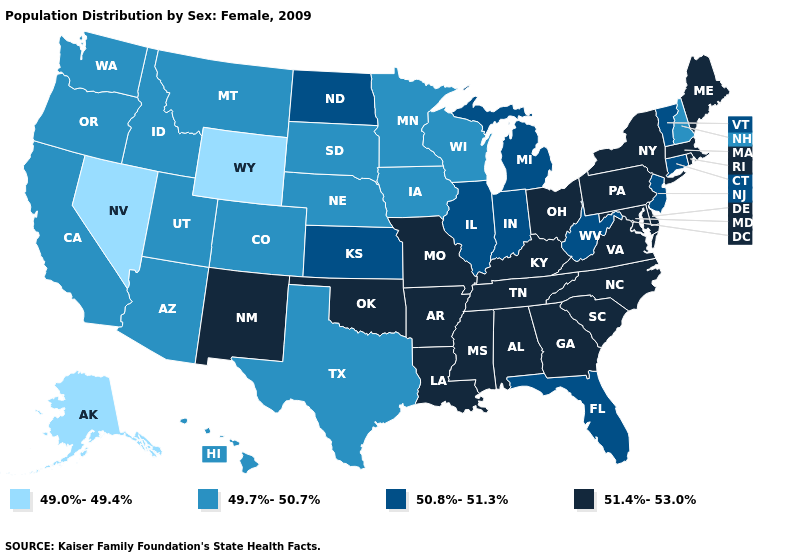What is the lowest value in the USA?
Answer briefly. 49.0%-49.4%. Which states have the lowest value in the USA?
Give a very brief answer. Alaska, Nevada, Wyoming. What is the lowest value in states that border Nebraska?
Concise answer only. 49.0%-49.4%. Does the map have missing data?
Be succinct. No. What is the value of Nebraska?
Be succinct. 49.7%-50.7%. What is the highest value in the Northeast ?
Keep it brief. 51.4%-53.0%. What is the highest value in states that border Pennsylvania?
Quick response, please. 51.4%-53.0%. Among the states that border Texas , which have the highest value?
Give a very brief answer. Arkansas, Louisiana, New Mexico, Oklahoma. Among the states that border Ohio , which have the lowest value?
Answer briefly. Indiana, Michigan, West Virginia. Does Arkansas have a higher value than North Carolina?
Keep it brief. No. Which states have the lowest value in the South?
Short answer required. Texas. Name the states that have a value in the range 51.4%-53.0%?
Keep it brief. Alabama, Arkansas, Delaware, Georgia, Kentucky, Louisiana, Maine, Maryland, Massachusetts, Mississippi, Missouri, New Mexico, New York, North Carolina, Ohio, Oklahoma, Pennsylvania, Rhode Island, South Carolina, Tennessee, Virginia. What is the value of Oklahoma?
Concise answer only. 51.4%-53.0%. Name the states that have a value in the range 49.0%-49.4%?
Keep it brief. Alaska, Nevada, Wyoming. Which states have the highest value in the USA?
Give a very brief answer. Alabama, Arkansas, Delaware, Georgia, Kentucky, Louisiana, Maine, Maryland, Massachusetts, Mississippi, Missouri, New Mexico, New York, North Carolina, Ohio, Oklahoma, Pennsylvania, Rhode Island, South Carolina, Tennessee, Virginia. 